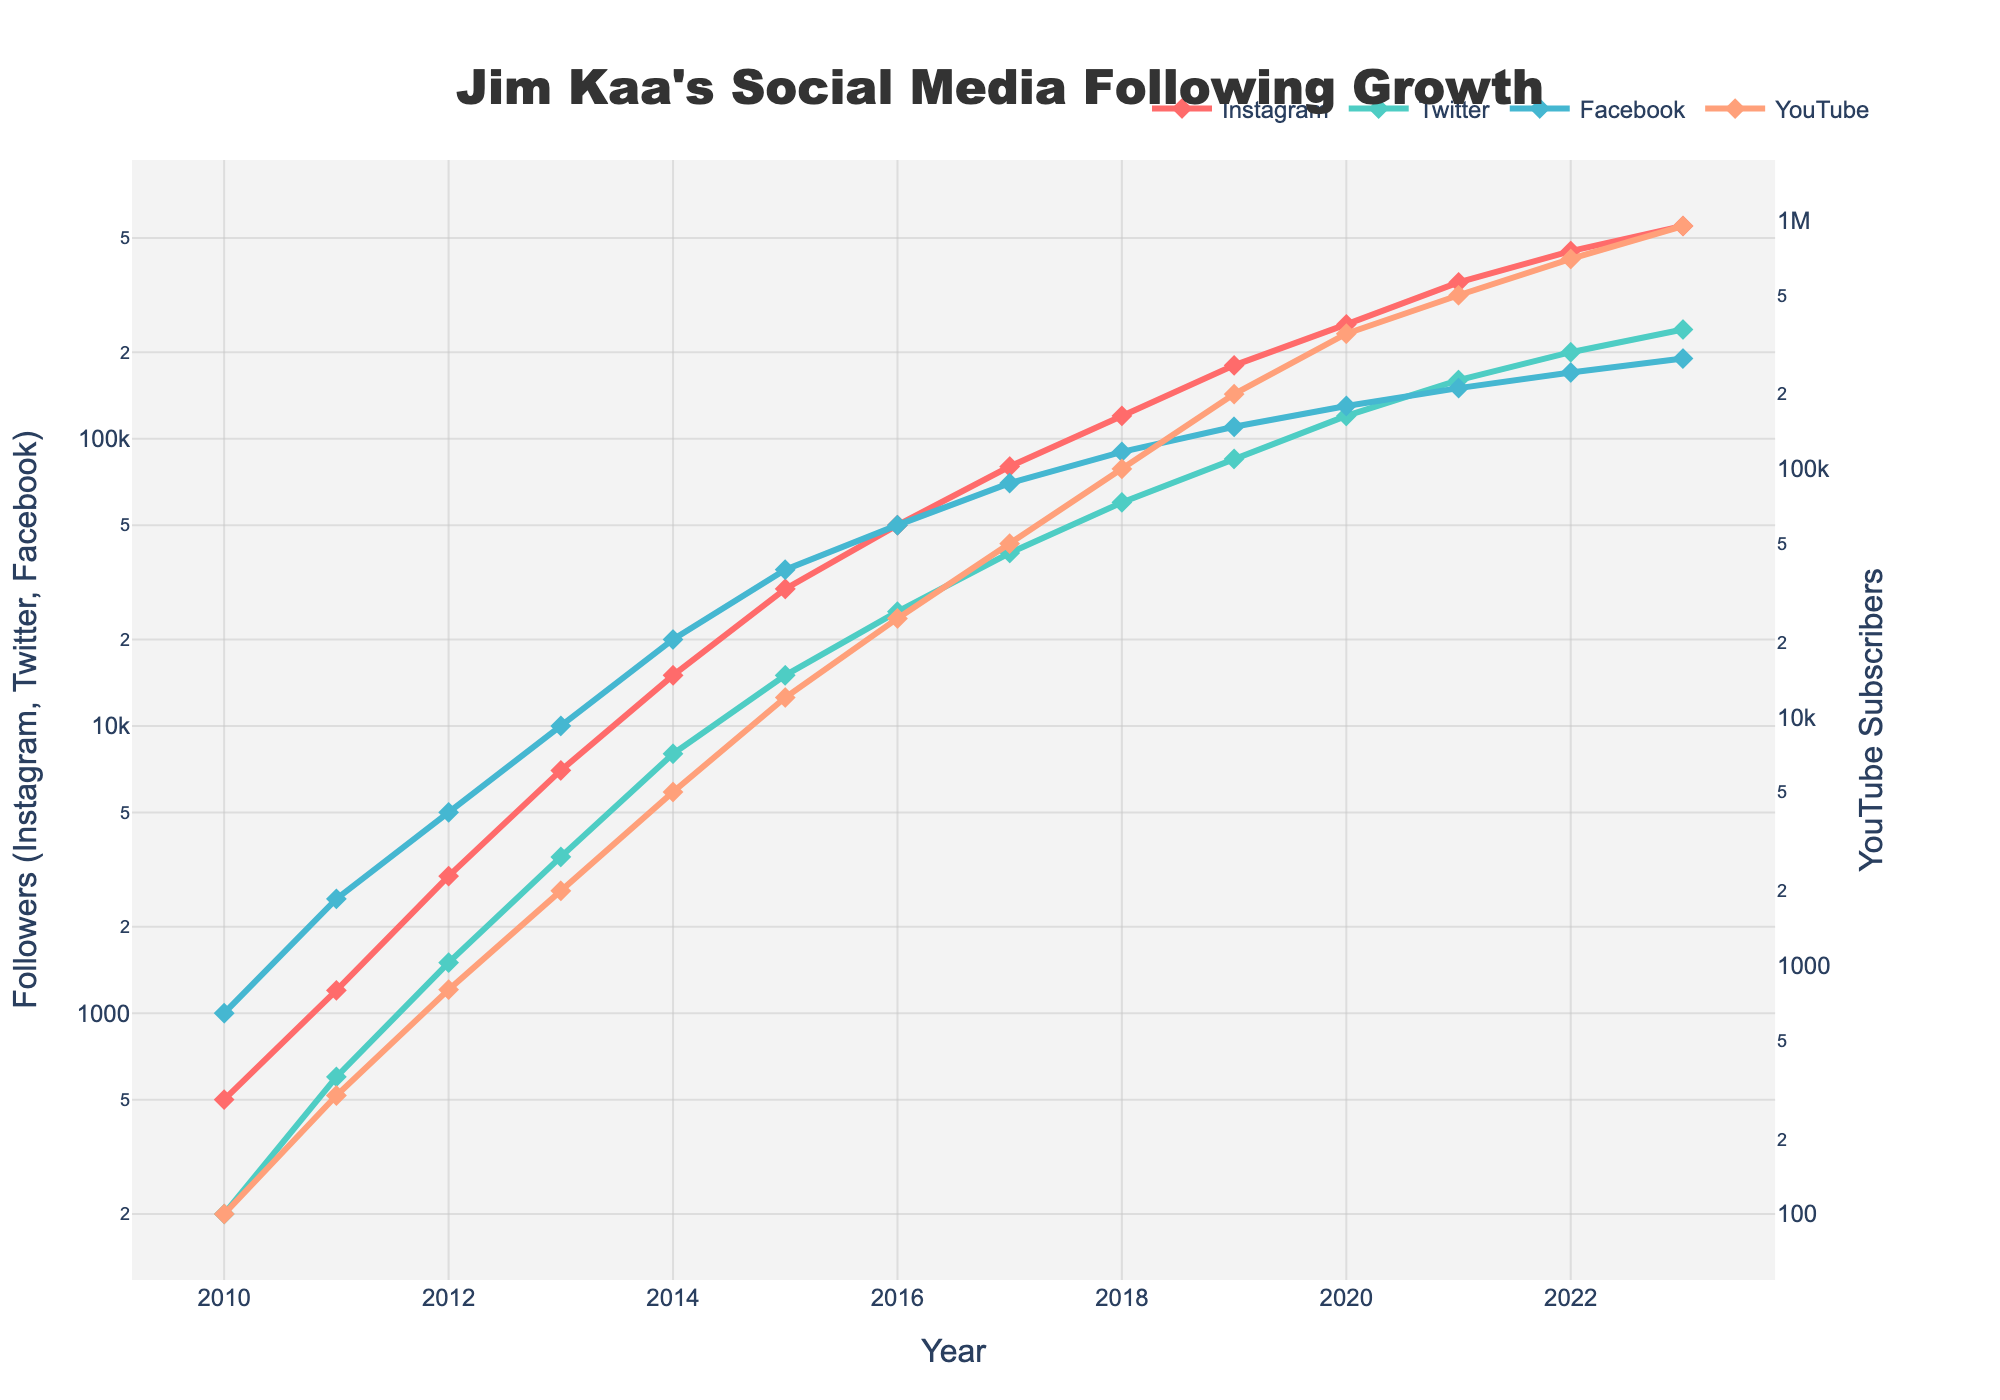What year did Jim Kaa's social media following on Instagram surpass 100,000? Examining the line graph for Instagram, we see the curve crosses the 100,000 mark between 2017 and 2018. Check the exact years and values: In 2018, the follower count is 120,000, which exceeds 100,000.
Answer: 2018 In which year did Jim Kaa have the same number of Facebook followers as Twitter followers in the previous year? Looking at the numbers, Twitter had 40,000 followers in 2017. In the following year, 2018, Facebook also had 40,000 followers.
Answer: 2018 What is the difference in YouTube subscribers between 2022 and 2016? The YouTube subscriber count in 2022 is 700,000, and in 2016 it is 25,000. The difference is 700,000 - 25,000.
Answer: 675,000 Which platform had the highest growth rate between 2019 and 2020? Comparing the growth rates: Instagram grew by 70,000 (250,000 - 180,000), Twitter by 35,000 (120,000 - 85,000), Facebook by 20,000 (130,000 - 110,000), and YouTube by 150,000 (350,000 - 200,000). The highest growth rate is on YouTube.
Answer: YouTube How many total followers did Jim Kaa have across all platforms in 2015? Summing followers on all platforms in 2015: Instagram (30,000) + Twitter (15,000) + Facebook (35,000) + YouTube (12,000). Total = 30,000 + 15,000 + 35,000 + 12,000.
Answer: 92,000 What was the overall trend for Jim Kaa's Facebook following from 2010 to 2023? Observing the Facebook line, it starts at 1,000 in 2010 and steadily increases to 190,000 in 2023. The trend is a consistent growth over the years.
Answer: Increasing steadily In which year was the increase in Jim Kaa's Twitter following the largest compared to the previous year? Comparing annual increases: 
2010-2011: 400, 
2011-2012: 900, 
2012-2013: 2000, 
2013-2014: 4500, 
2014-2015: 7000, 
2015-2016: 10000, 
2016-2017: 15000, 
2017-2018: 20000, 
2018-2019: 25000, 
2019-2020: 35000, 
2020-2021: 40000, 
2021-2022: 40000, 
2022-2023: 40000. 
The largest increase is from 2019 to 2020.
Answer: 2019-2020 What is the ratio of YouTube subscribers to Instagram followers in 2023? In 2023, YouTube has 950,000 subscribers and Instagram has 550,000 followers. The ratio is 950,000 / 550,000.
Answer: Approximately 1.73 By how much did Instagram followers increase from 2013 to 2014? Instagram followers in 2013 were 7,000 and in 2014 were 15,000. The increase is 15,000 - 7,000.
Answer: 8,000 